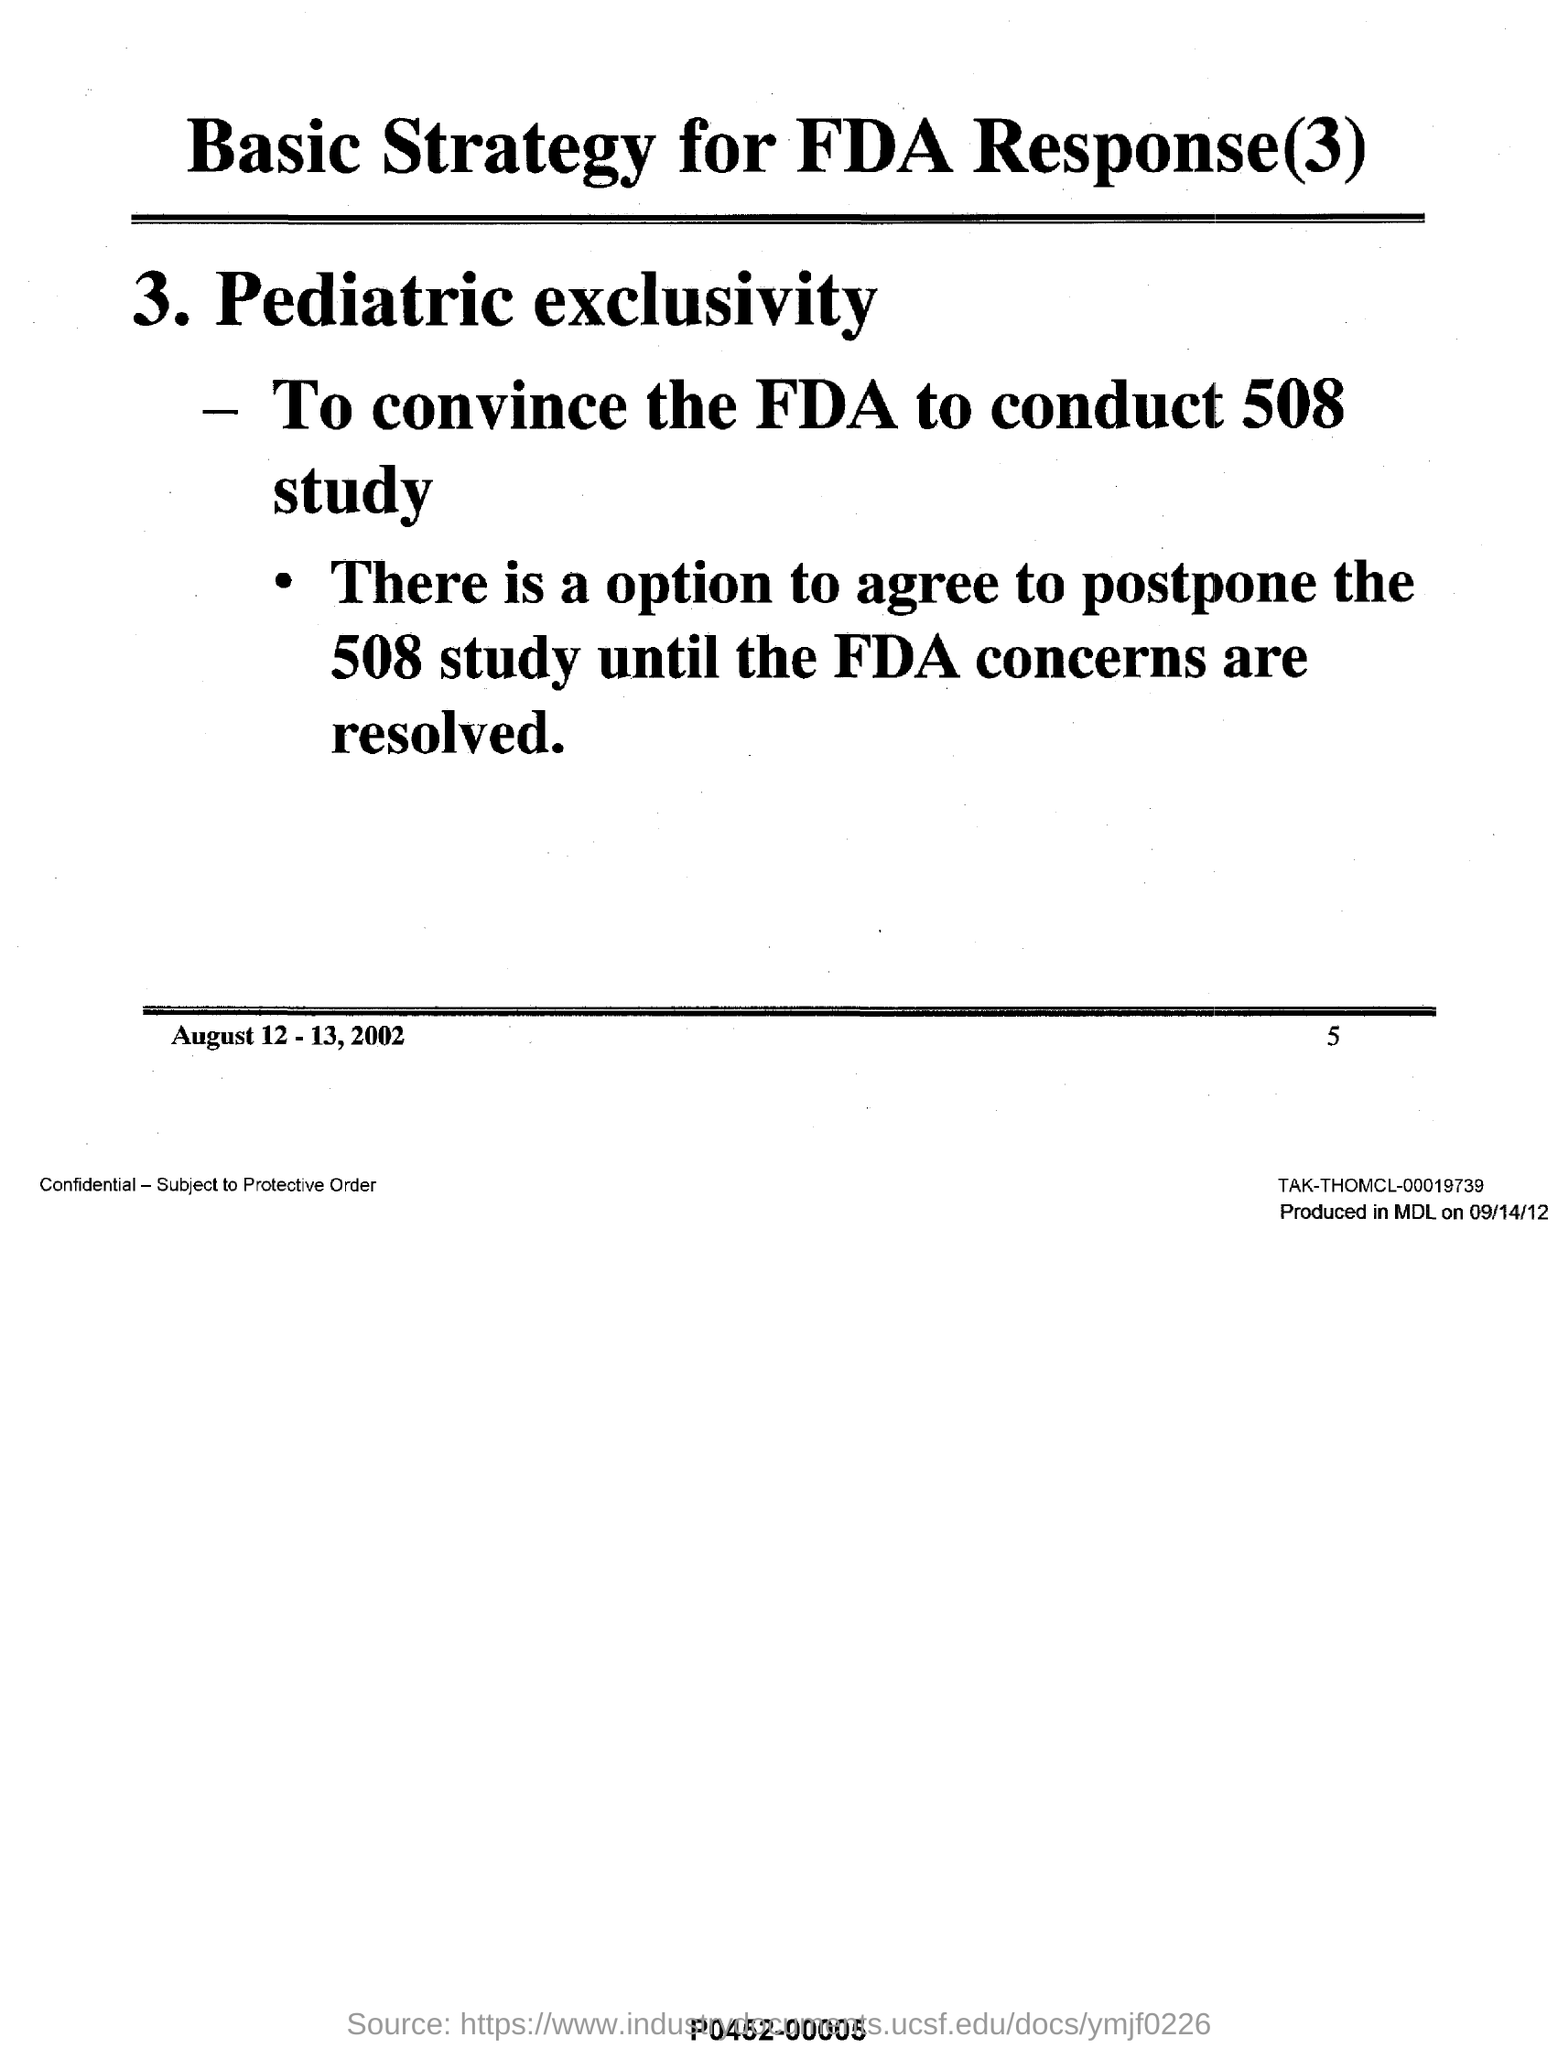Mention a couple of crucial points in this snapshot. The page number mentioned in this document is 5. The date range mentioned in this document is August 12-13, 2002. This document is titled 'Basic Strategy for FDA Response(3)'. 